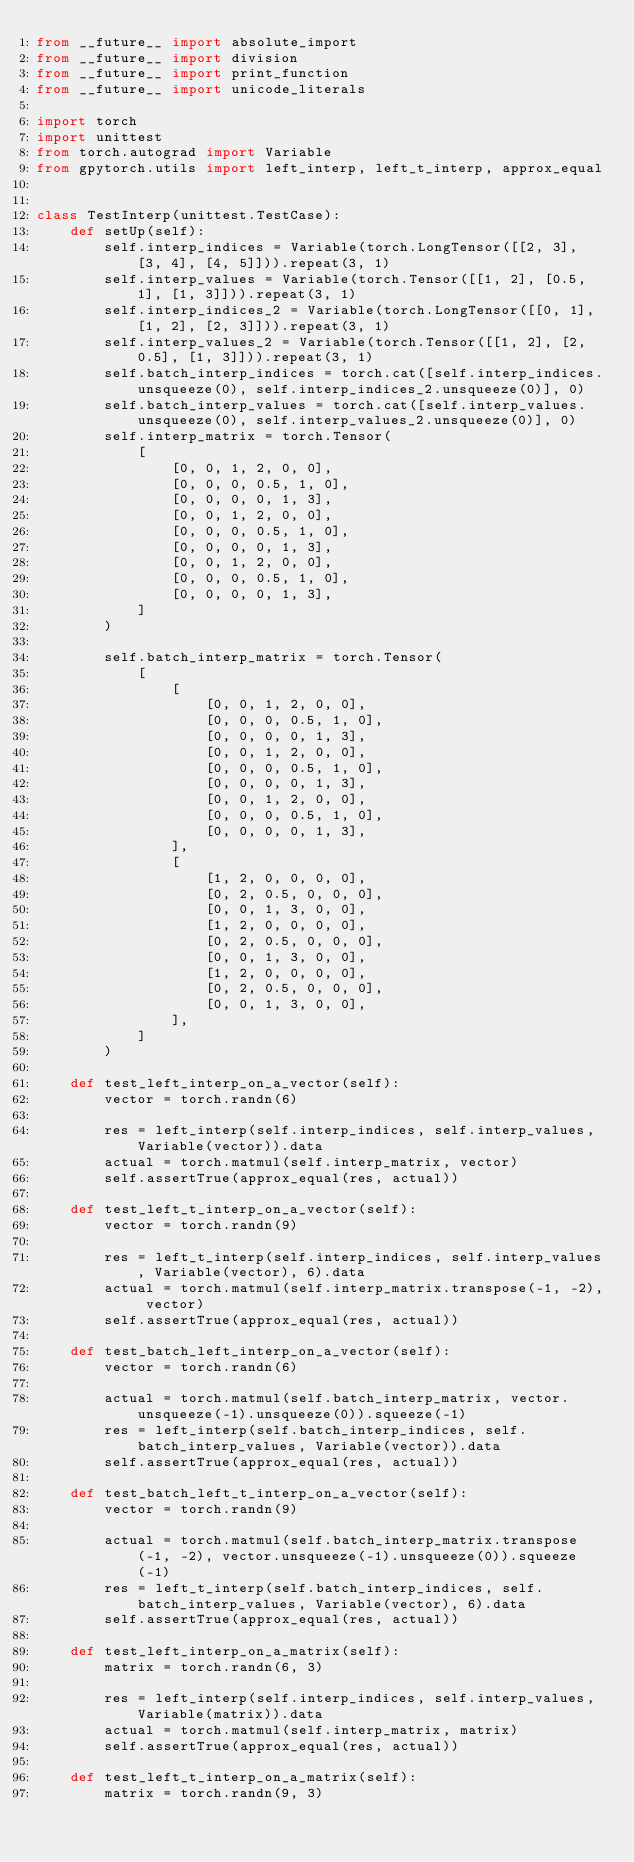Convert code to text. <code><loc_0><loc_0><loc_500><loc_500><_Python_>from __future__ import absolute_import
from __future__ import division
from __future__ import print_function
from __future__ import unicode_literals

import torch
import unittest
from torch.autograd import Variable
from gpytorch.utils import left_interp, left_t_interp, approx_equal


class TestInterp(unittest.TestCase):
    def setUp(self):
        self.interp_indices = Variable(torch.LongTensor([[2, 3], [3, 4], [4, 5]])).repeat(3, 1)
        self.interp_values = Variable(torch.Tensor([[1, 2], [0.5, 1], [1, 3]])).repeat(3, 1)
        self.interp_indices_2 = Variable(torch.LongTensor([[0, 1], [1, 2], [2, 3]])).repeat(3, 1)
        self.interp_values_2 = Variable(torch.Tensor([[1, 2], [2, 0.5], [1, 3]])).repeat(3, 1)
        self.batch_interp_indices = torch.cat([self.interp_indices.unsqueeze(0), self.interp_indices_2.unsqueeze(0)], 0)
        self.batch_interp_values = torch.cat([self.interp_values.unsqueeze(0), self.interp_values_2.unsqueeze(0)], 0)
        self.interp_matrix = torch.Tensor(
            [
                [0, 0, 1, 2, 0, 0],
                [0, 0, 0, 0.5, 1, 0],
                [0, 0, 0, 0, 1, 3],
                [0, 0, 1, 2, 0, 0],
                [0, 0, 0, 0.5, 1, 0],
                [0, 0, 0, 0, 1, 3],
                [0, 0, 1, 2, 0, 0],
                [0, 0, 0, 0.5, 1, 0],
                [0, 0, 0, 0, 1, 3],
            ]
        )

        self.batch_interp_matrix = torch.Tensor(
            [
                [
                    [0, 0, 1, 2, 0, 0],
                    [0, 0, 0, 0.5, 1, 0],
                    [0, 0, 0, 0, 1, 3],
                    [0, 0, 1, 2, 0, 0],
                    [0, 0, 0, 0.5, 1, 0],
                    [0, 0, 0, 0, 1, 3],
                    [0, 0, 1, 2, 0, 0],
                    [0, 0, 0, 0.5, 1, 0],
                    [0, 0, 0, 0, 1, 3],
                ],
                [
                    [1, 2, 0, 0, 0, 0],
                    [0, 2, 0.5, 0, 0, 0],
                    [0, 0, 1, 3, 0, 0],
                    [1, 2, 0, 0, 0, 0],
                    [0, 2, 0.5, 0, 0, 0],
                    [0, 0, 1, 3, 0, 0],
                    [1, 2, 0, 0, 0, 0],
                    [0, 2, 0.5, 0, 0, 0],
                    [0, 0, 1, 3, 0, 0],
                ],
            ]
        )

    def test_left_interp_on_a_vector(self):
        vector = torch.randn(6)

        res = left_interp(self.interp_indices, self.interp_values, Variable(vector)).data
        actual = torch.matmul(self.interp_matrix, vector)
        self.assertTrue(approx_equal(res, actual))

    def test_left_t_interp_on_a_vector(self):
        vector = torch.randn(9)

        res = left_t_interp(self.interp_indices, self.interp_values, Variable(vector), 6).data
        actual = torch.matmul(self.interp_matrix.transpose(-1, -2), vector)
        self.assertTrue(approx_equal(res, actual))

    def test_batch_left_interp_on_a_vector(self):
        vector = torch.randn(6)

        actual = torch.matmul(self.batch_interp_matrix, vector.unsqueeze(-1).unsqueeze(0)).squeeze(-1)
        res = left_interp(self.batch_interp_indices, self.batch_interp_values, Variable(vector)).data
        self.assertTrue(approx_equal(res, actual))

    def test_batch_left_t_interp_on_a_vector(self):
        vector = torch.randn(9)

        actual = torch.matmul(self.batch_interp_matrix.transpose(-1, -2), vector.unsqueeze(-1).unsqueeze(0)).squeeze(-1)
        res = left_t_interp(self.batch_interp_indices, self.batch_interp_values, Variable(vector), 6).data
        self.assertTrue(approx_equal(res, actual))

    def test_left_interp_on_a_matrix(self):
        matrix = torch.randn(6, 3)

        res = left_interp(self.interp_indices, self.interp_values, Variable(matrix)).data
        actual = torch.matmul(self.interp_matrix, matrix)
        self.assertTrue(approx_equal(res, actual))

    def test_left_t_interp_on_a_matrix(self):
        matrix = torch.randn(9, 3)
</code> 